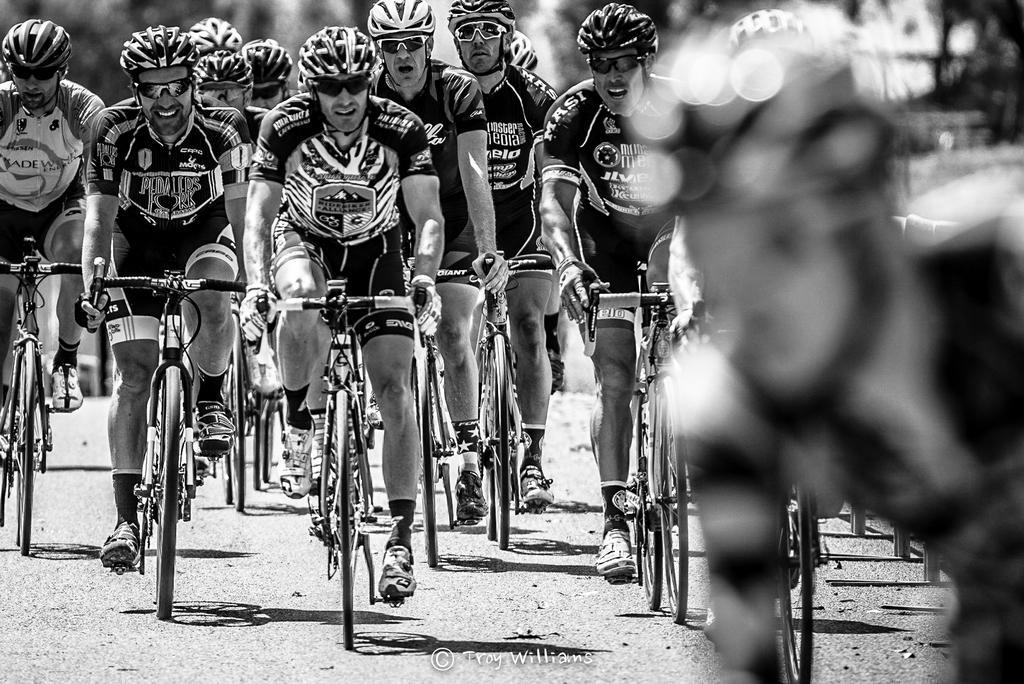Could you give a brief overview of what you see in this image? In this we can see a group of people riding their bicycles wearing the helmet and shades. 